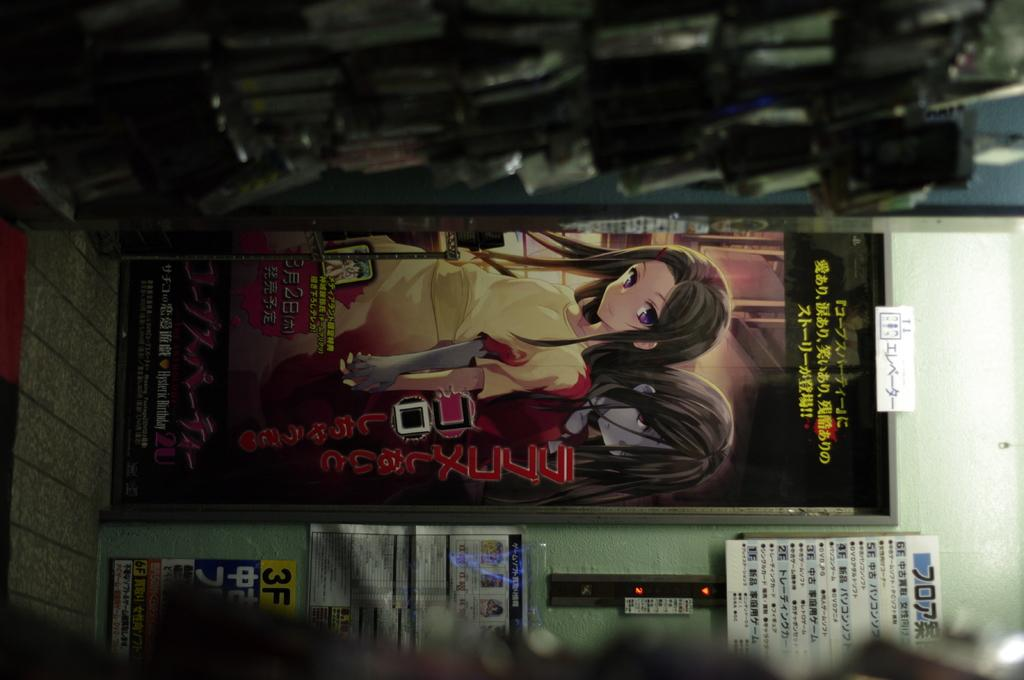What is depicted on the poster in the image? The poster features two Barbie girls. Can you describe the poster's appearance? The poster is in the image, and its background is blurred. How many umbrellas are being used by the Barbie girls in the image? There are no umbrellas present in the image; the poster features two Barbie girls without any umbrellas. Can you describe the type of cart the Barbie girls are riding in the image? There is no cart present in the image; the poster features two Barbie girls without any carts. 